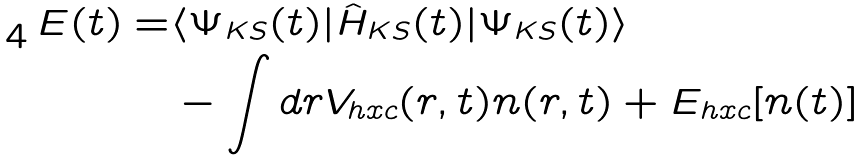Convert formula to latex. <formula><loc_0><loc_0><loc_500><loc_500>E ( t ) = & \langle \Psi _ { K S } ( t ) | \hat { H } _ { K S } ( t ) | \Psi _ { K S } ( t ) \rangle \\ & - \int d r V _ { h x c } ( r , t ) n ( r , t ) + E _ { h x c } [ n ( t ) ]</formula> 